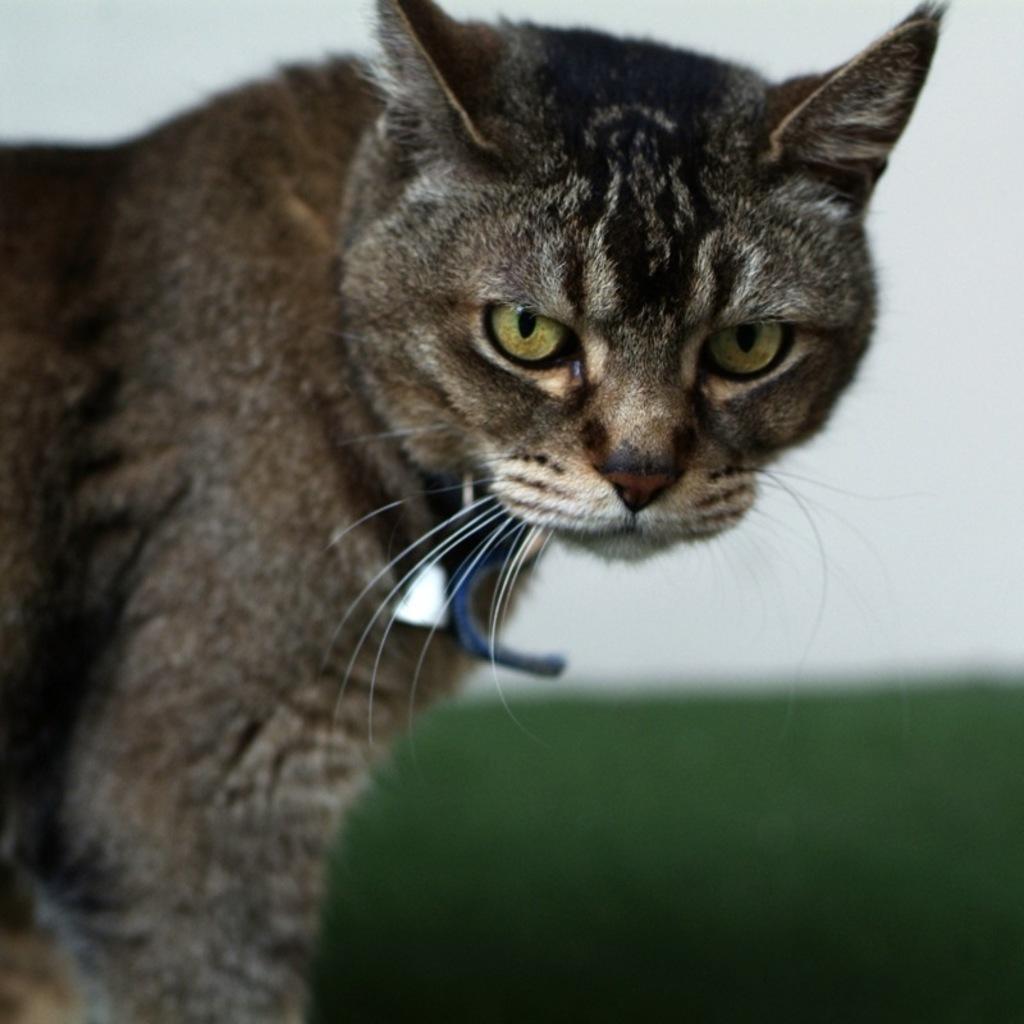Describe this image in one or two sentences. In this picture there is a cat. I can see the rope on his neck. In the back I can see the wall. 